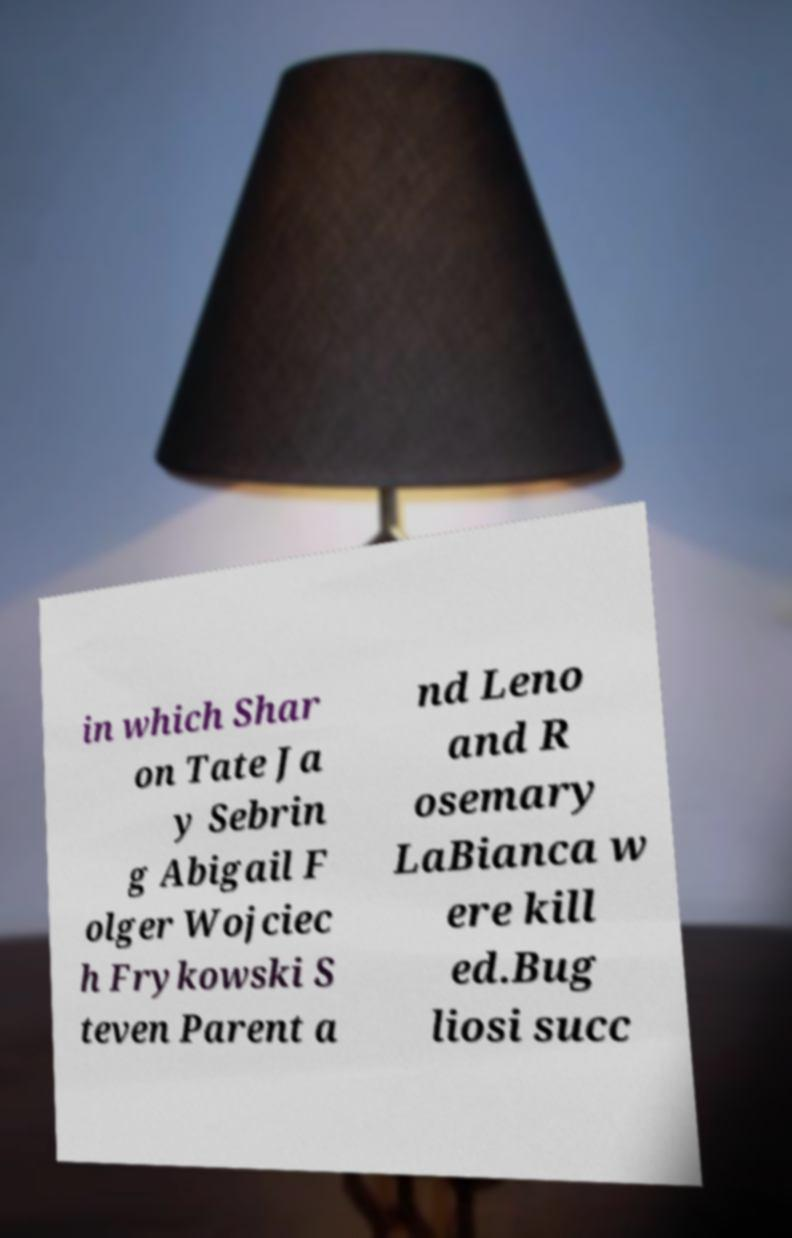What messages or text are displayed in this image? I need them in a readable, typed format. in which Shar on Tate Ja y Sebrin g Abigail F olger Wojciec h Frykowski S teven Parent a nd Leno and R osemary LaBianca w ere kill ed.Bug liosi succ 